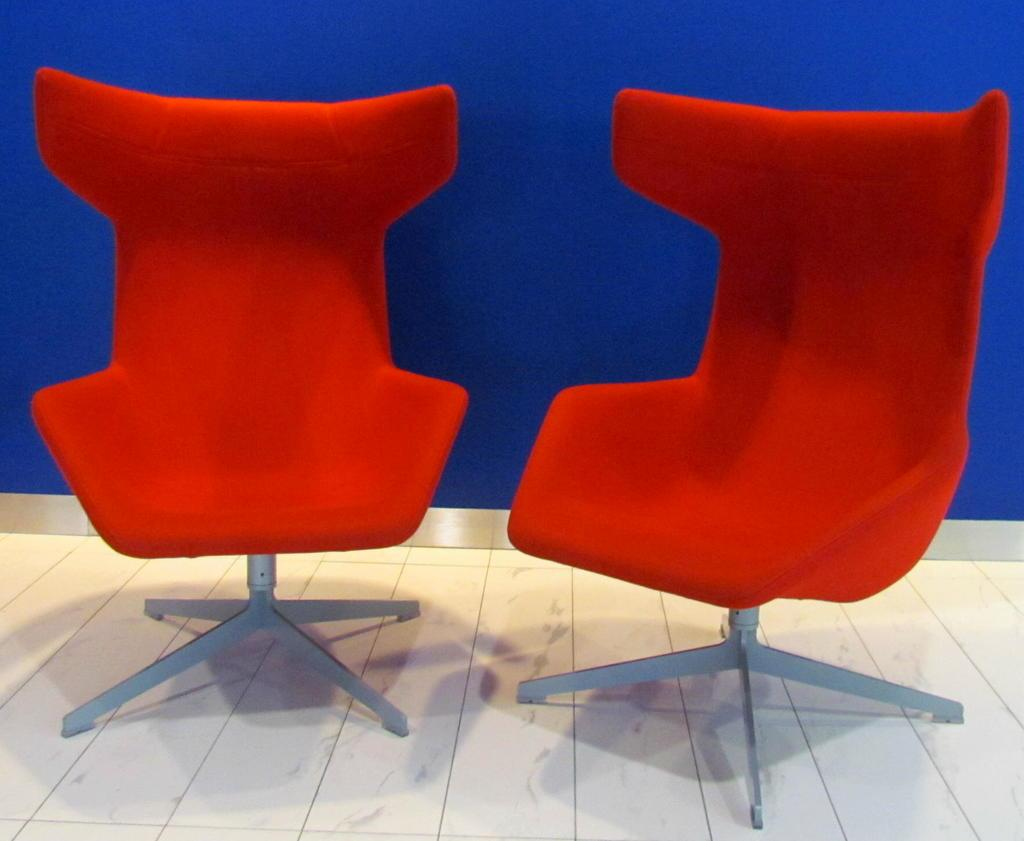What type of furniture is present in the image? There are two red color chairs in the image. What can be seen at the bottom of the image? There is a floor visible towards the bottom of the image. What color is the wall in the background of the image? There is a blue color wall in the background of the image. What is the name of the lake visible in the image? There is no lake present in the image; it only features two red chairs, a floor, and a blue wall in the background. 